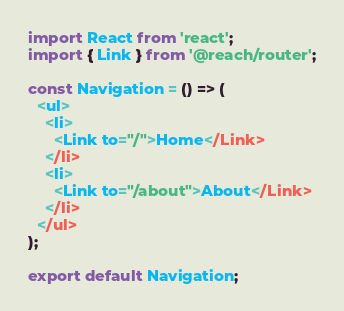<code> <loc_0><loc_0><loc_500><loc_500><_JavaScript_>import React from 'react';
import { Link } from '@reach/router';

const Navigation = () => (
  <ul>
    <li>
      <Link to="/">Home</Link>
    </li>
    <li>
      <Link to="/about">About</Link>
    </li>
  </ul>
);

export default Navigation;
</code> 